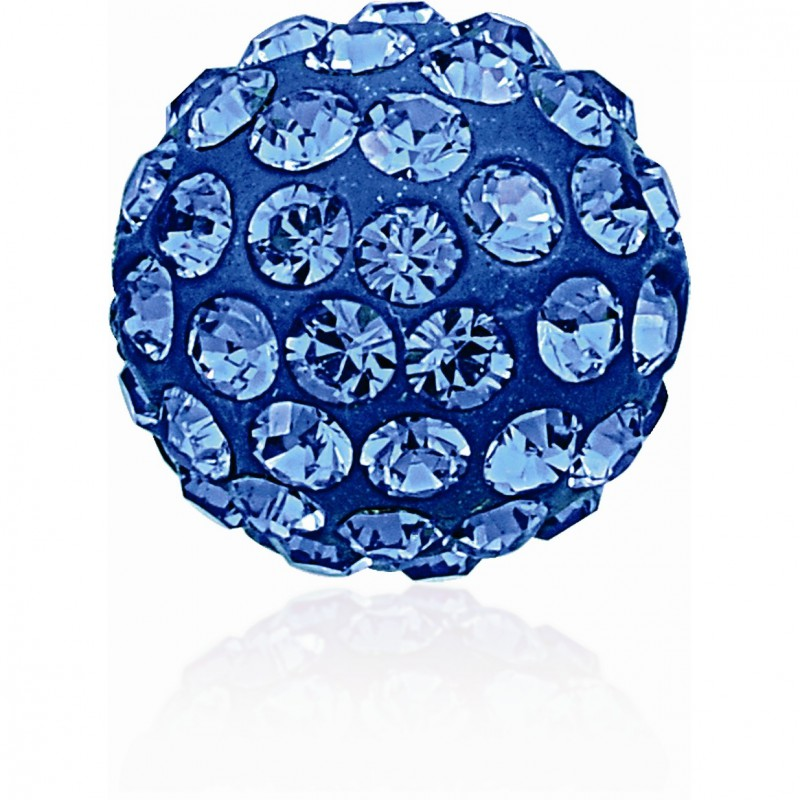Based on the arrangement and size variation of the gemstones, what could be the possible reason for the use of different sized gemstones in this pattern? The use of different sized gemstones in this pattern serves multiple aesthetic and practical purposes. Firstly, varying the sizes helps to fill the surface area more completely, ensuring a tighter fit with minimal gaps between the stones, which can create a more polished and seamless look. Additionally, this technique adds a captivating visual depth and texture, making the piece more appealing and dynamic. By integrating stones of different sizes, the designer achieves a more intricate and layered design that catches light in unique ways, enhancing the overall sparkle and brilliance of the piece. This method can also lead to a harmonious, balanced pattern that draws the eye and keeps the viewer's interest. 